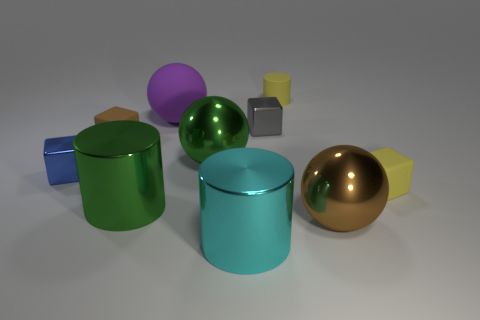Subtract all tiny yellow matte cubes. How many cubes are left? 3 Subtract 1 green cylinders. How many objects are left? 9 Subtract all cubes. How many objects are left? 6 Subtract 3 spheres. How many spheres are left? 0 Subtract all purple cylinders. Subtract all brown blocks. How many cylinders are left? 3 Subtract all green cylinders. How many brown blocks are left? 1 Subtract all yellow matte things. Subtract all tiny objects. How many objects are left? 3 Add 7 metallic cylinders. How many metallic cylinders are left? 9 Add 5 brown metal spheres. How many brown metal spheres exist? 6 Subtract all gray blocks. How many blocks are left? 3 